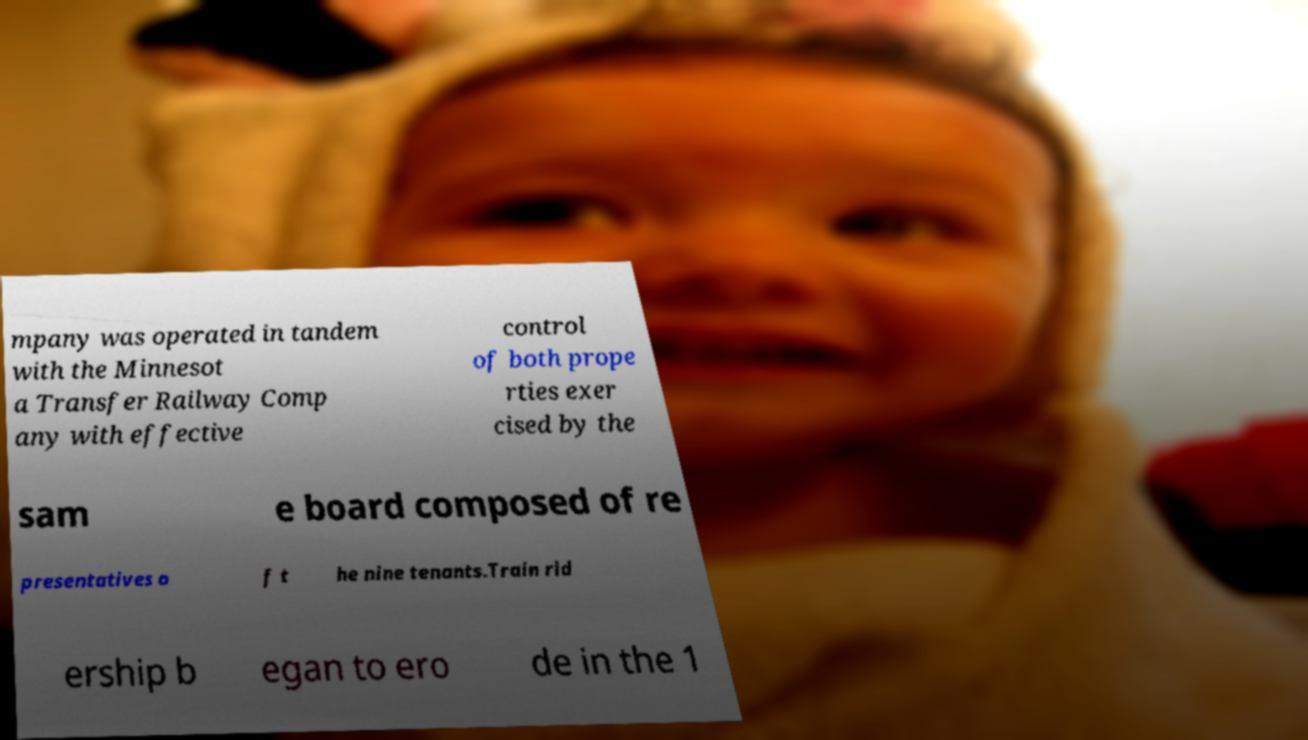Can you read and provide the text displayed in the image?This photo seems to have some interesting text. Can you extract and type it out for me? mpany was operated in tandem with the Minnesot a Transfer Railway Comp any with effective control of both prope rties exer cised by the sam e board composed of re presentatives o f t he nine tenants.Train rid ership b egan to ero de in the 1 